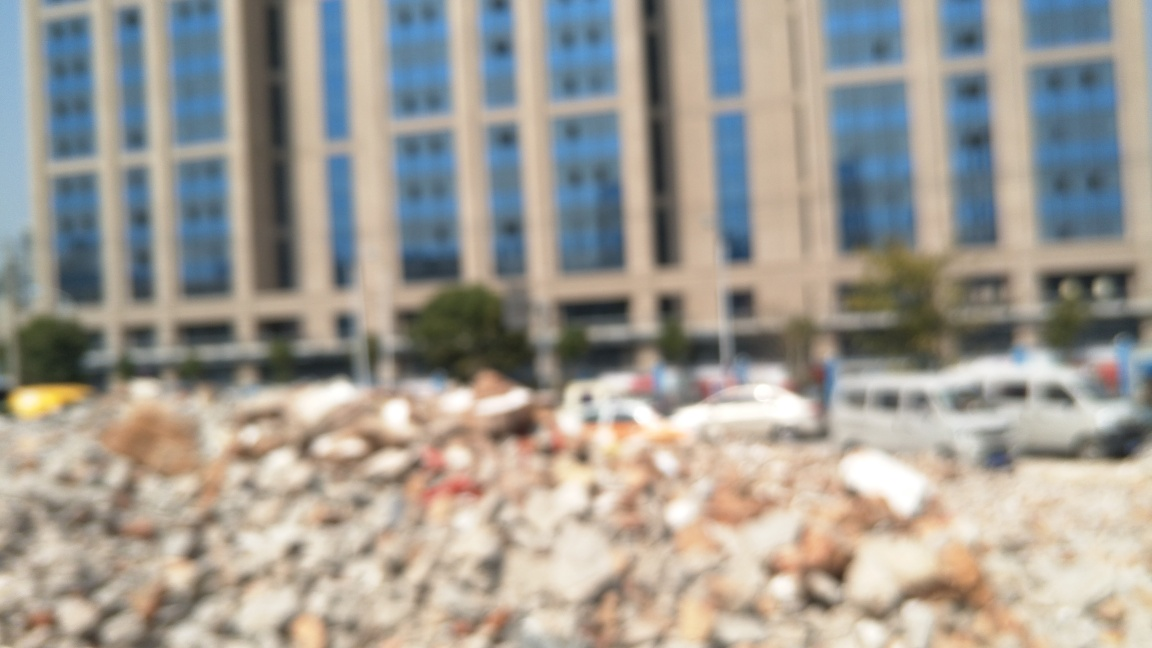What is the composition of this image?
A. Perfectly composed
B. Average
C. Exceptional
Answer with the option's letter from the given choices directly. While the option B was selected, indicating an 'Average' composition, it's important to note that the image appears to be intentionally blurred, which suggests a creative motive or technical limitation rather than a reflection of composition skill. The foreground is cluttered with what appears to be demolished building materials, contrasting sharply with the more orderly and structured buildings in the background. Although this juxtaposition adds a layer of visual interest, overall, the blurring effect dominates the frame, leading to a less conventional and not typically 'average' composition. 